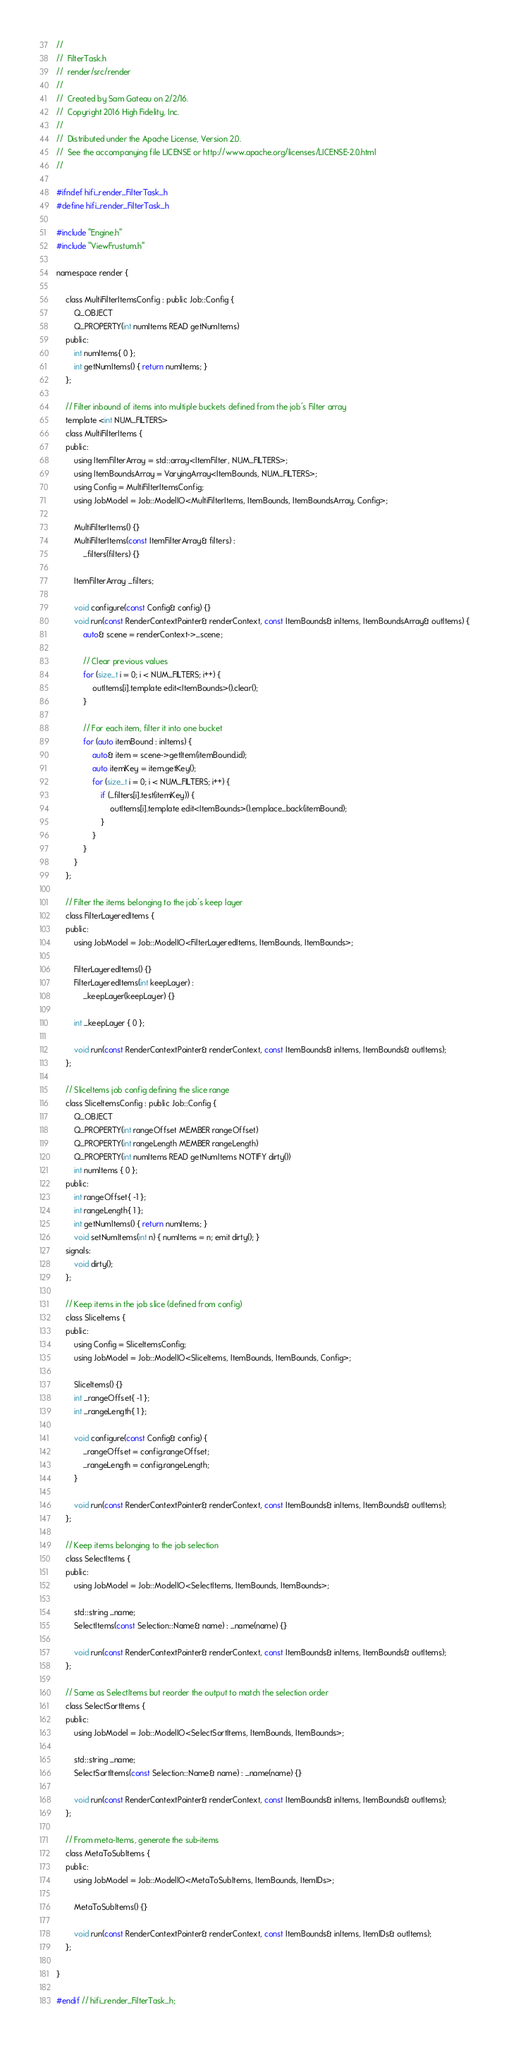Convert code to text. <code><loc_0><loc_0><loc_500><loc_500><_C_>//
//  FilterTask.h
//  render/src/render
//
//  Created by Sam Gateau on 2/2/16.
//  Copyright 2016 High Fidelity, Inc.
//
//  Distributed under the Apache License, Version 2.0.
//  See the accompanying file LICENSE or http://www.apache.org/licenses/LICENSE-2.0.html
//

#ifndef hifi_render_FilterTask_h
#define hifi_render_FilterTask_h

#include "Engine.h"
#include "ViewFrustum.h"

namespace render {

    class MultiFilterItemsConfig : public Job::Config {
        Q_OBJECT
        Q_PROPERTY(int numItems READ getNumItems)
    public:
        int numItems{ 0 };
        int getNumItems() { return numItems; }
    };

    // Filter inbound of items into multiple buckets defined from the job's Filter array
    template <int NUM_FILTERS>
    class MultiFilterItems {
    public:
        using ItemFilterArray = std::array<ItemFilter, NUM_FILTERS>;
        using ItemBoundsArray = VaryingArray<ItemBounds, NUM_FILTERS>;
        using Config = MultiFilterItemsConfig;
        using JobModel = Job::ModelIO<MultiFilterItems, ItemBounds, ItemBoundsArray, Config>;

        MultiFilterItems() {}
        MultiFilterItems(const ItemFilterArray& filters) :
            _filters(filters) {}

        ItemFilterArray _filters;

        void configure(const Config& config) {}
        void run(const RenderContextPointer& renderContext, const ItemBounds& inItems, ItemBoundsArray& outItems) {
            auto& scene = renderContext->_scene;
            
            // Clear previous values
            for (size_t i = 0; i < NUM_FILTERS; i++) {
                outItems[i].template edit<ItemBounds>().clear();
            }

            // For each item, filter it into one bucket
            for (auto itemBound : inItems) {
                auto& item = scene->getItem(itemBound.id);
                auto itemKey = item.getKey();
                for (size_t i = 0; i < NUM_FILTERS; i++) {
                    if (_filters[i].test(itemKey)) {
                        outItems[i].template edit<ItemBounds>().emplace_back(itemBound);
                    }
                }
            }
        }
    };

    // Filter the items belonging to the job's keep layer
    class FilterLayeredItems {
    public:
        using JobModel = Job::ModelIO<FilterLayeredItems, ItemBounds, ItemBounds>;

        FilterLayeredItems() {}
        FilterLayeredItems(int keepLayer) :
            _keepLayer(keepLayer) {}

        int _keepLayer { 0 };

        void run(const RenderContextPointer& renderContext, const ItemBounds& inItems, ItemBounds& outItems);
    };

    // SliceItems job config defining the slice range
    class SliceItemsConfig : public Job::Config {
        Q_OBJECT
        Q_PROPERTY(int rangeOffset MEMBER rangeOffset)
        Q_PROPERTY(int rangeLength MEMBER rangeLength)
        Q_PROPERTY(int numItems READ getNumItems NOTIFY dirty())
        int numItems { 0 };
    public:
        int rangeOffset{ -1 };
        int rangeLength{ 1 };
        int getNumItems() { return numItems; }
        void setNumItems(int n) { numItems = n; emit dirty(); }
    signals:
        void dirty();
    };

    // Keep items in the job slice (defined from config)
    class SliceItems {
    public:
        using Config = SliceItemsConfig;
        using JobModel = Job::ModelIO<SliceItems, ItemBounds, ItemBounds, Config>;
        
        SliceItems() {}
        int _rangeOffset{ -1 };
        int _rangeLength{ 1 };
        
        void configure(const Config& config) {
            _rangeOffset = config.rangeOffset;
            _rangeLength = config.rangeLength;
        }

        void run(const RenderContextPointer& renderContext, const ItemBounds& inItems, ItemBounds& outItems);
    };
    
    // Keep items belonging to the job selection
    class SelectItems {
    public:
        using JobModel = Job::ModelIO<SelectItems, ItemBounds, ItemBounds>;
        
        std::string _name;
        SelectItems(const Selection::Name& name) : _name(name) {}
        
        void run(const RenderContextPointer& renderContext, const ItemBounds& inItems, ItemBounds& outItems);
    };

    // Same as SelectItems but reorder the output to match the selection order
    class SelectSortItems {
    public:
        using JobModel = Job::ModelIO<SelectSortItems, ItemBounds, ItemBounds>;
        
        std::string _name;
        SelectSortItems(const Selection::Name& name) : _name(name) {}
        
        void run(const RenderContextPointer& renderContext, const ItemBounds& inItems, ItemBounds& outItems);
    };

    // From meta-Items, generate the sub-items
    class MetaToSubItems {
    public:
        using JobModel = Job::ModelIO<MetaToSubItems, ItemBounds, ItemIDs>;

        MetaToSubItems() {}

        void run(const RenderContextPointer& renderContext, const ItemBounds& inItems, ItemIDs& outItems);
    };

}

#endif // hifi_render_FilterTask_h;</code> 